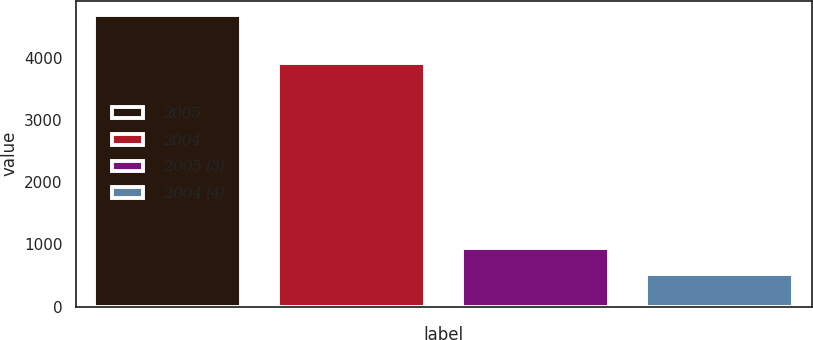Convert chart to OTSL. <chart><loc_0><loc_0><loc_500><loc_500><bar_chart><fcel>2005<fcel>2004<fcel>2005 (3)<fcel>2004 (4)<nl><fcel>4680<fcel>3910<fcel>937.8<fcel>522<nl></chart> 